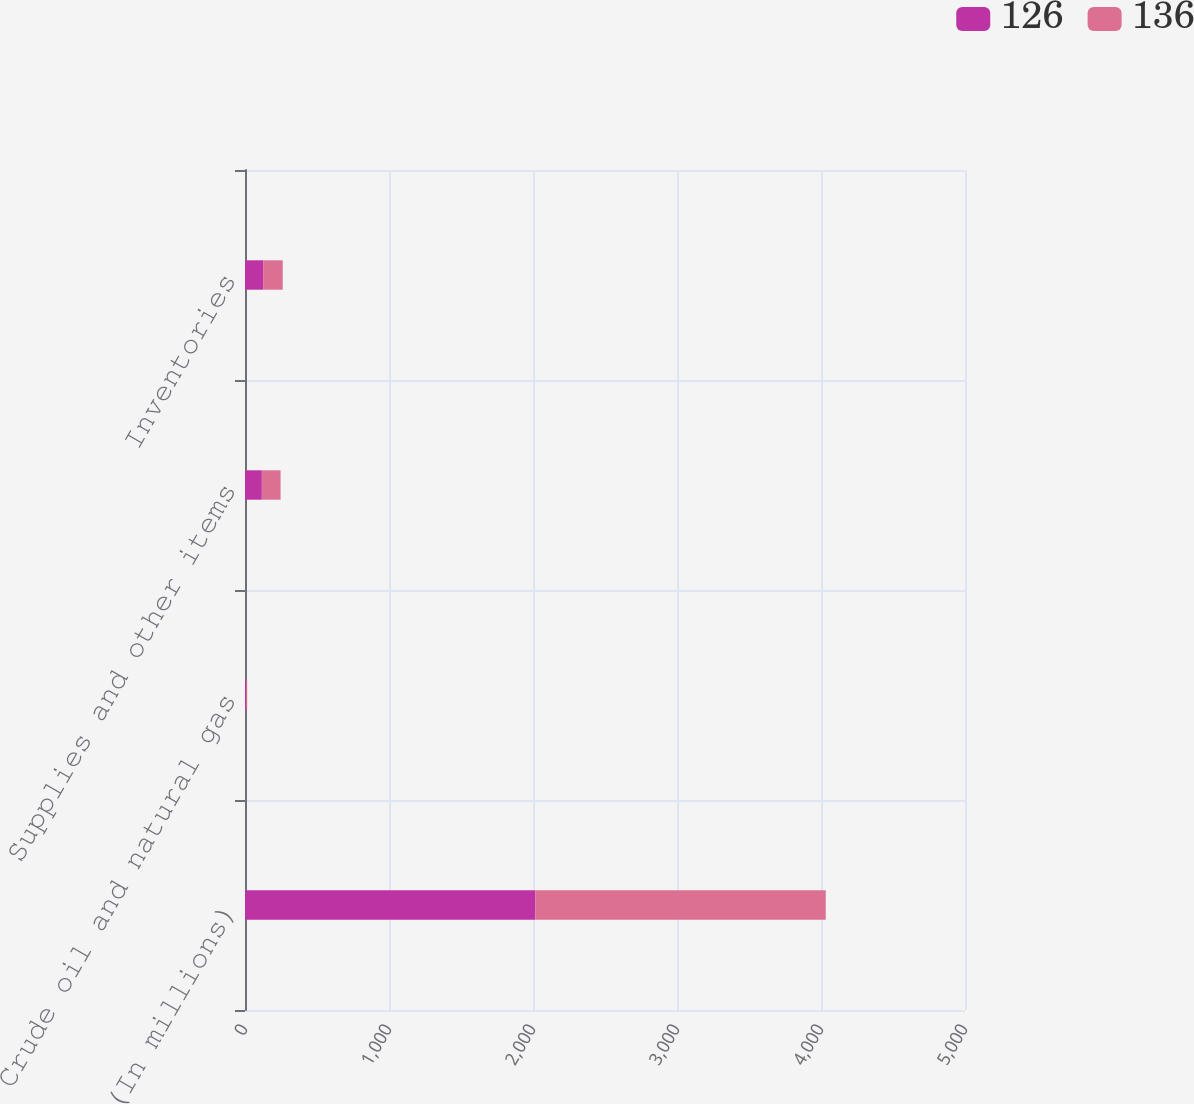Convert chart to OTSL. <chart><loc_0><loc_0><loc_500><loc_500><stacked_bar_chart><ecel><fcel>(In millions)<fcel>Crude oil and natural gas<fcel>Supplies and other items<fcel>Inventories<nl><fcel>126<fcel>2017<fcel>9<fcel>117<fcel>126<nl><fcel>136<fcel>2016<fcel>6<fcel>130<fcel>136<nl></chart> 